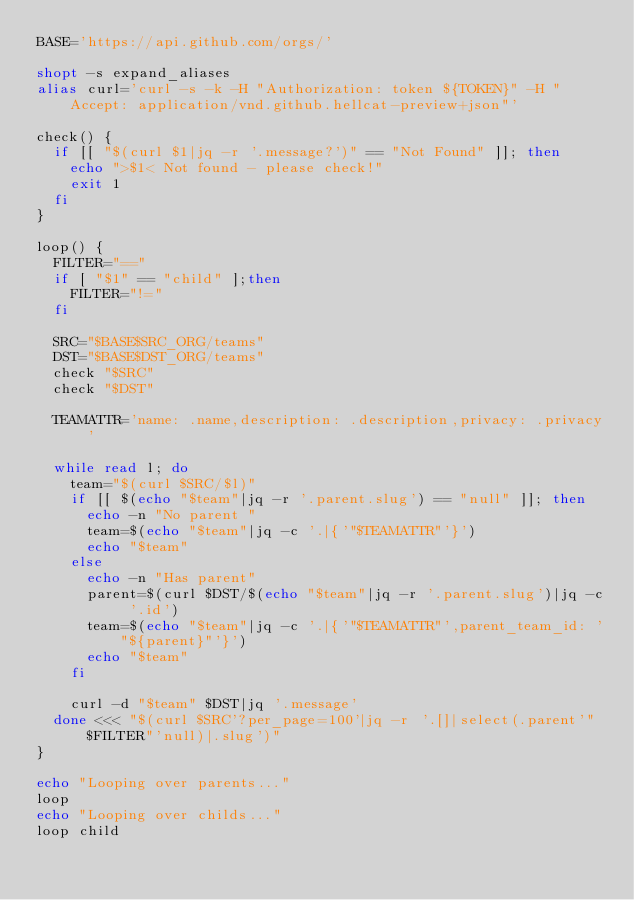Convert code to text. <code><loc_0><loc_0><loc_500><loc_500><_Bash_>BASE='https://api.github.com/orgs/'

shopt -s expand_aliases
alias curl='curl -s -k -H "Authorization: token ${TOKEN}" -H "Accept: application/vnd.github.hellcat-preview+json"'

check() {
  if [[ "$(curl $1|jq -r '.message?')" == "Not Found" ]]; then
    echo ">$1< Not found - please check!"
    exit 1
  fi
}

loop() {
  FILTER="=="
  if [ "$1" == "child" ];then
    FILTER="!="
  fi

  SRC="$BASE$SRC_ORG/teams"
  DST="$BASE$DST_ORG/teams"
  check "$SRC"
  check "$DST"
  
  TEAMATTR='name: .name,description: .description,privacy: .privacy'

  while read l; do
    team="$(curl $SRC/$l)"
    if [[ $(echo "$team"|jq -r '.parent.slug') == "null" ]]; then
      echo -n "No parent "
      team=$(echo "$team"|jq -c '.|{'"$TEAMATTR"'}')
      echo "$team"
    else
      echo -n "Has parent"
      parent=$(curl $DST/$(echo "$team"|jq -r '.parent.slug')|jq -c '.id')
      team=$(echo "$team"|jq -c '.|{'"$TEAMATTR"',parent_team_id: '"${parent}"'}')
      echo "$team"
    fi
    
    curl -d "$team" $DST|jq '.message'
  done <<< "$(curl $SRC'?per_page=100'|jq -r '.[]|select(.parent'"$FILTER"'null)|.slug')"
}

echo "Looping over parents..."
loop
echo "Looping over childs..."
loop child
</code> 